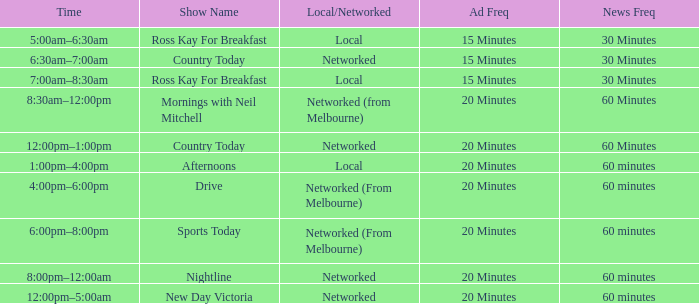What Time has a Show Name of mornings with neil mitchell? 8:30am–12:00pm. 